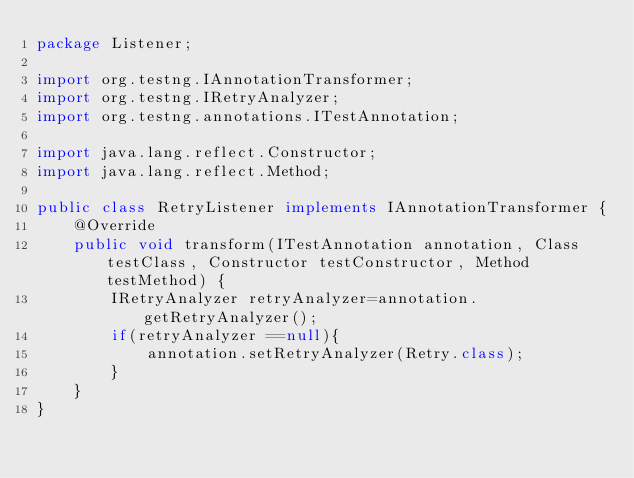Convert code to text. <code><loc_0><loc_0><loc_500><loc_500><_Java_>package Listener;

import org.testng.IAnnotationTransformer;
import org.testng.IRetryAnalyzer;
import org.testng.annotations.ITestAnnotation;

import java.lang.reflect.Constructor;
import java.lang.reflect.Method;

public class RetryListener implements IAnnotationTransformer {
    @Override
    public void transform(ITestAnnotation annotation, Class testClass, Constructor testConstructor, Method testMethod) {
        IRetryAnalyzer retryAnalyzer=annotation.getRetryAnalyzer();
        if(retryAnalyzer ==null){
            annotation.setRetryAnalyzer(Retry.class);
        }
    }
}
</code> 